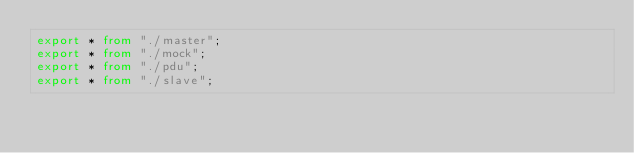Convert code to text. <code><loc_0><loc_0><loc_500><loc_500><_TypeScript_>export * from "./master";
export * from "./mock";
export * from "./pdu";
export * from "./slave";
</code> 